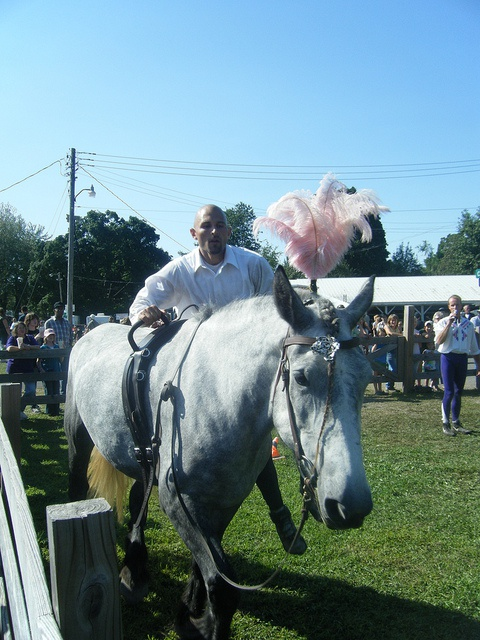Describe the objects in this image and their specific colors. I can see horse in lightblue, black, lightgray, darkgray, and gray tones, people in lightblue, gray, black, and white tones, people in lightblue, black, gray, and navy tones, people in lightblue, black, navy, gray, and blue tones, and people in lightblue, black, navy, gray, and blue tones in this image. 